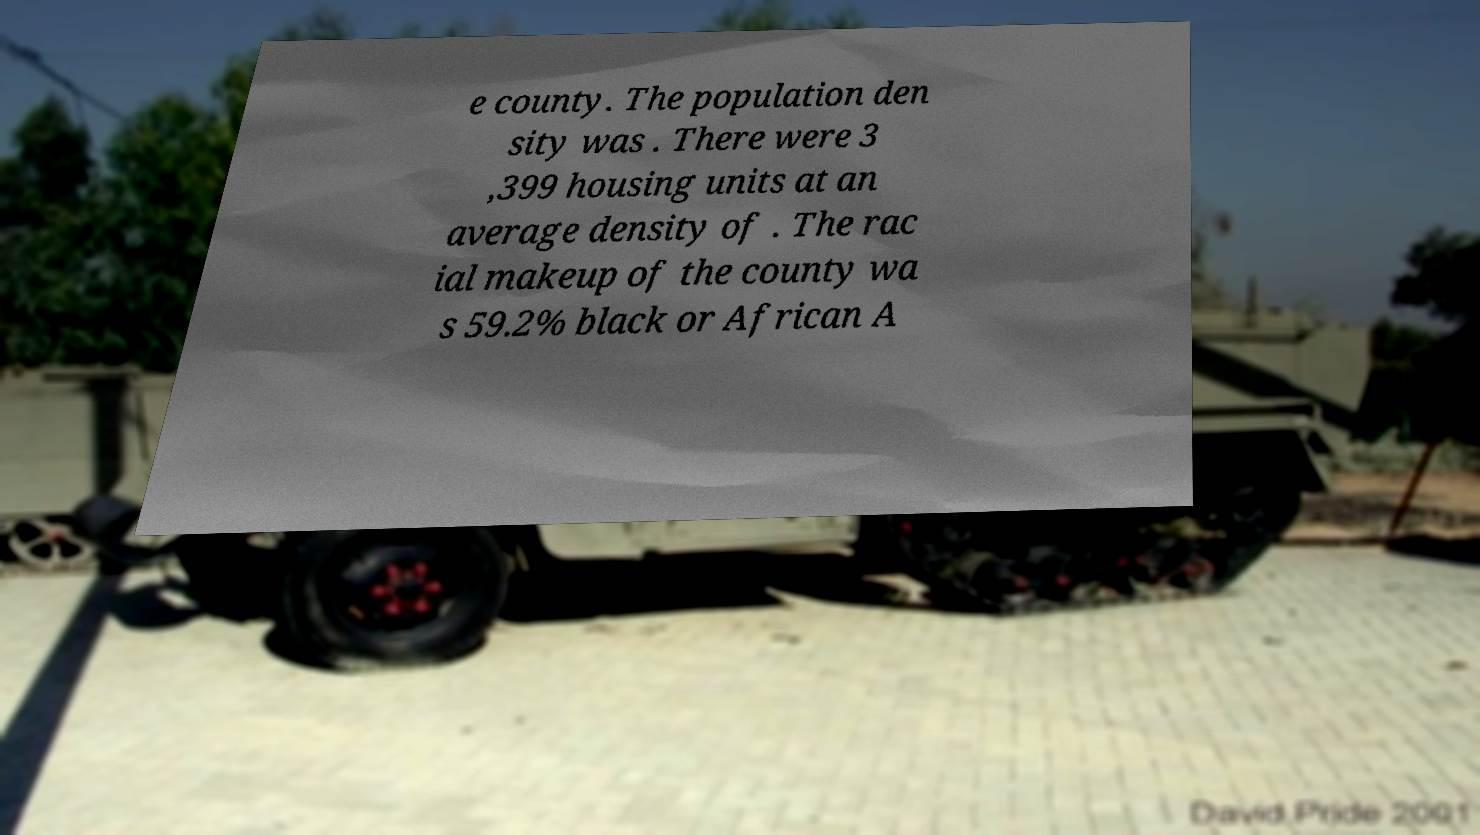For documentation purposes, I need the text within this image transcribed. Could you provide that? e county. The population den sity was . There were 3 ,399 housing units at an average density of . The rac ial makeup of the county wa s 59.2% black or African A 